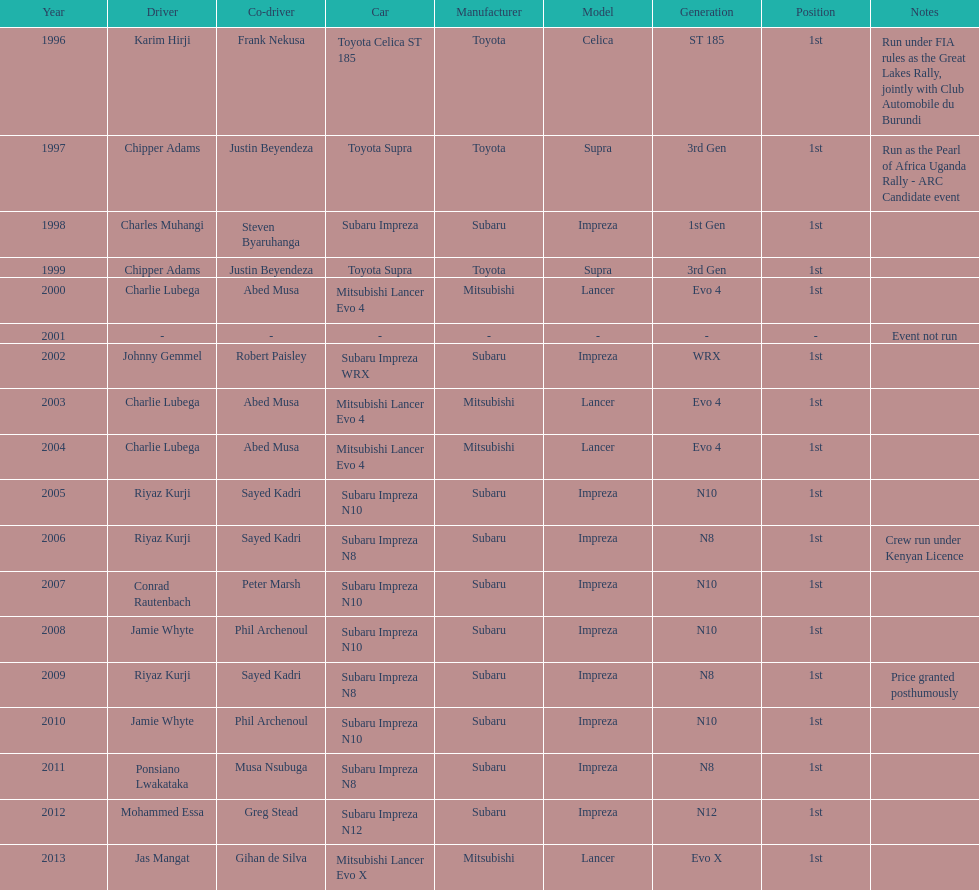Who was the only driver to win in a car other than a subaru impreza after the year 2005? Jas Mangat. 